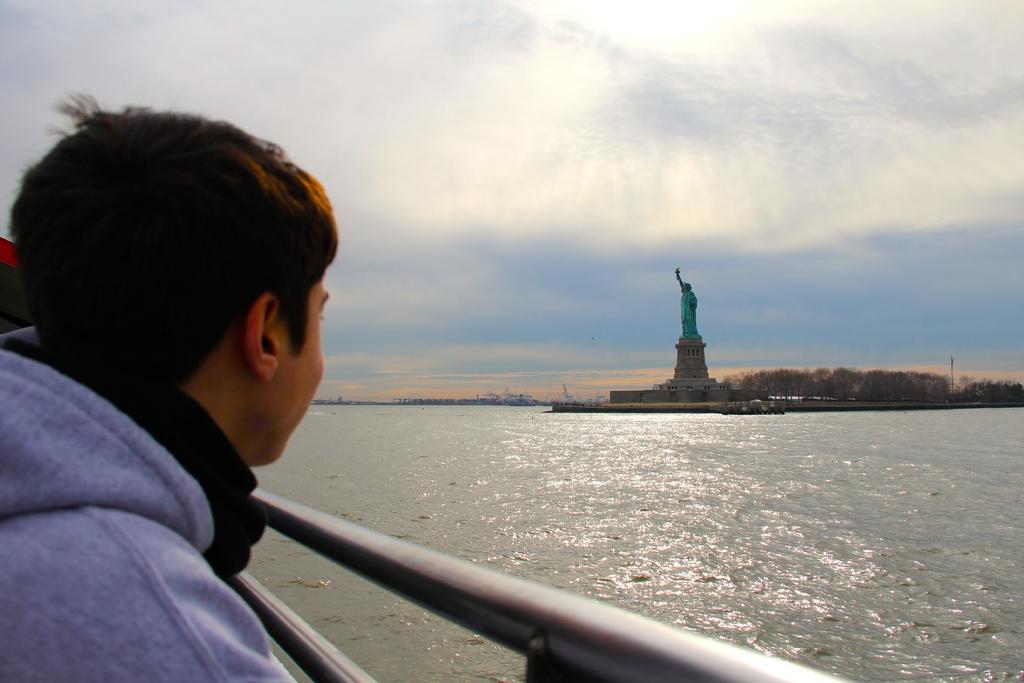Can you describe this image briefly? In this picture we can see a boy at fence and he is looking at a statue where this statue is in the middle of water and the background we can see trees, sky with clouds. 